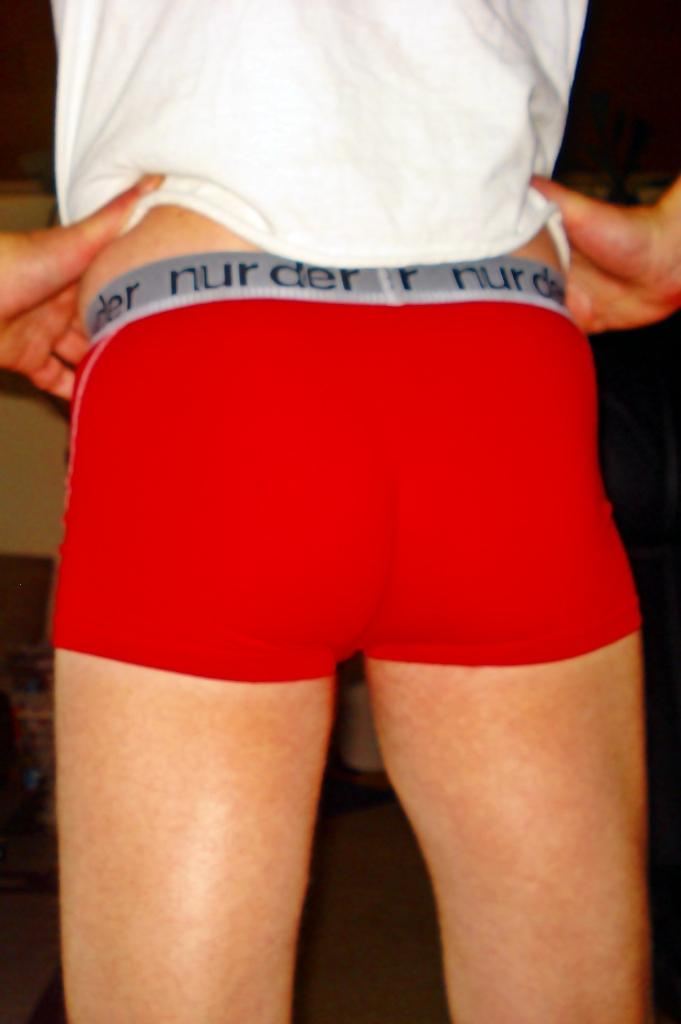<image>
Create a compact narrative representing the image presented. Someone is wearing red boxers with 'nur der' written along the waistband. 